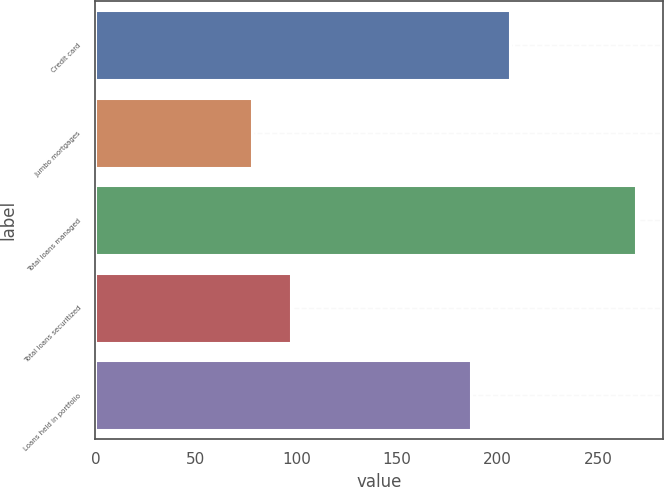Convert chart to OTSL. <chart><loc_0><loc_0><loc_500><loc_500><bar_chart><fcel>Credit card<fcel>Jumbo mortgages<fcel>Total loans managed<fcel>Total loans securitized<fcel>Loans held in portfolio<nl><fcel>206.1<fcel>78<fcel>269<fcel>97.1<fcel>187<nl></chart> 